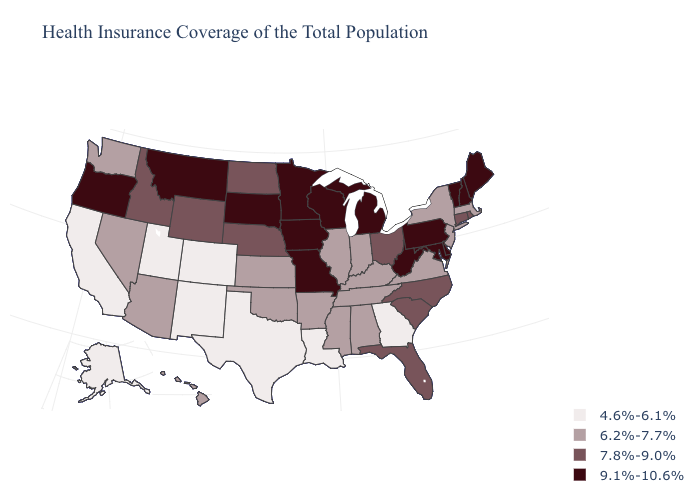What is the value of Ohio?
Keep it brief. 7.8%-9.0%. Name the states that have a value in the range 7.8%-9.0%?
Short answer required. Connecticut, Florida, Idaho, Nebraska, North Carolina, North Dakota, Ohio, Rhode Island, South Carolina, Wyoming. Does Vermont have the lowest value in the Northeast?
Quick response, please. No. What is the value of Minnesota?
Be succinct. 9.1%-10.6%. What is the value of Vermont?
Give a very brief answer. 9.1%-10.6%. What is the highest value in states that border Oklahoma?
Quick response, please. 9.1%-10.6%. Name the states that have a value in the range 7.8%-9.0%?
Write a very short answer. Connecticut, Florida, Idaho, Nebraska, North Carolina, North Dakota, Ohio, Rhode Island, South Carolina, Wyoming. Among the states that border Idaho , which have the highest value?
Answer briefly. Montana, Oregon. Name the states that have a value in the range 9.1%-10.6%?
Keep it brief. Delaware, Iowa, Maine, Maryland, Michigan, Minnesota, Missouri, Montana, New Hampshire, Oregon, Pennsylvania, South Dakota, Vermont, West Virginia, Wisconsin. Does the map have missing data?
Concise answer only. No. Among the states that border Rhode Island , which have the lowest value?
Give a very brief answer. Massachusetts. What is the highest value in the USA?
Give a very brief answer. 9.1%-10.6%. Which states have the lowest value in the USA?
Quick response, please. Alaska, California, Colorado, Georgia, Louisiana, New Mexico, Texas, Utah. Name the states that have a value in the range 9.1%-10.6%?
Be succinct. Delaware, Iowa, Maine, Maryland, Michigan, Minnesota, Missouri, Montana, New Hampshire, Oregon, Pennsylvania, South Dakota, Vermont, West Virginia, Wisconsin. Does Louisiana have the highest value in the USA?
Keep it brief. No. 